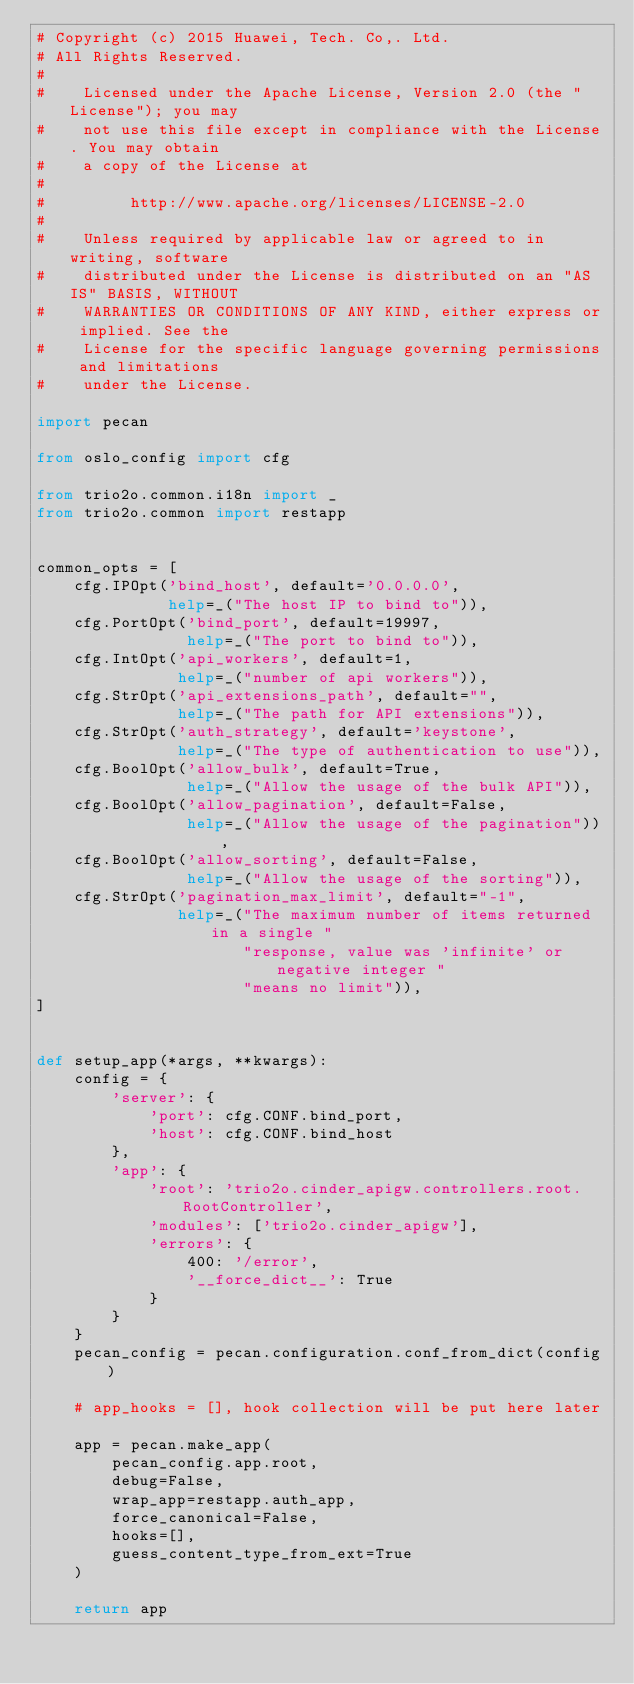<code> <loc_0><loc_0><loc_500><loc_500><_Python_># Copyright (c) 2015 Huawei, Tech. Co,. Ltd.
# All Rights Reserved.
#
#    Licensed under the Apache License, Version 2.0 (the "License"); you may
#    not use this file except in compliance with the License. You may obtain
#    a copy of the License at
#
#         http://www.apache.org/licenses/LICENSE-2.0
#
#    Unless required by applicable law or agreed to in writing, software
#    distributed under the License is distributed on an "AS IS" BASIS, WITHOUT
#    WARRANTIES OR CONDITIONS OF ANY KIND, either express or implied. See the
#    License for the specific language governing permissions and limitations
#    under the License.

import pecan

from oslo_config import cfg

from trio2o.common.i18n import _
from trio2o.common import restapp


common_opts = [
    cfg.IPOpt('bind_host', default='0.0.0.0',
              help=_("The host IP to bind to")),
    cfg.PortOpt('bind_port', default=19997,
                help=_("The port to bind to")),
    cfg.IntOpt('api_workers', default=1,
               help=_("number of api workers")),
    cfg.StrOpt('api_extensions_path', default="",
               help=_("The path for API extensions")),
    cfg.StrOpt('auth_strategy', default='keystone',
               help=_("The type of authentication to use")),
    cfg.BoolOpt('allow_bulk', default=True,
                help=_("Allow the usage of the bulk API")),
    cfg.BoolOpt('allow_pagination', default=False,
                help=_("Allow the usage of the pagination")),
    cfg.BoolOpt('allow_sorting', default=False,
                help=_("Allow the usage of the sorting")),
    cfg.StrOpt('pagination_max_limit', default="-1",
               help=_("The maximum number of items returned in a single "
                      "response, value was 'infinite' or negative integer "
                      "means no limit")),
]


def setup_app(*args, **kwargs):
    config = {
        'server': {
            'port': cfg.CONF.bind_port,
            'host': cfg.CONF.bind_host
        },
        'app': {
            'root': 'trio2o.cinder_apigw.controllers.root.RootController',
            'modules': ['trio2o.cinder_apigw'],
            'errors': {
                400: '/error',
                '__force_dict__': True
            }
        }
    }
    pecan_config = pecan.configuration.conf_from_dict(config)

    # app_hooks = [], hook collection will be put here later

    app = pecan.make_app(
        pecan_config.app.root,
        debug=False,
        wrap_app=restapp.auth_app,
        force_canonical=False,
        hooks=[],
        guess_content_type_from_ext=True
    )

    return app
</code> 